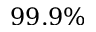Convert formula to latex. <formula><loc_0><loc_0><loc_500><loc_500>9 9 . 9 \%</formula> 